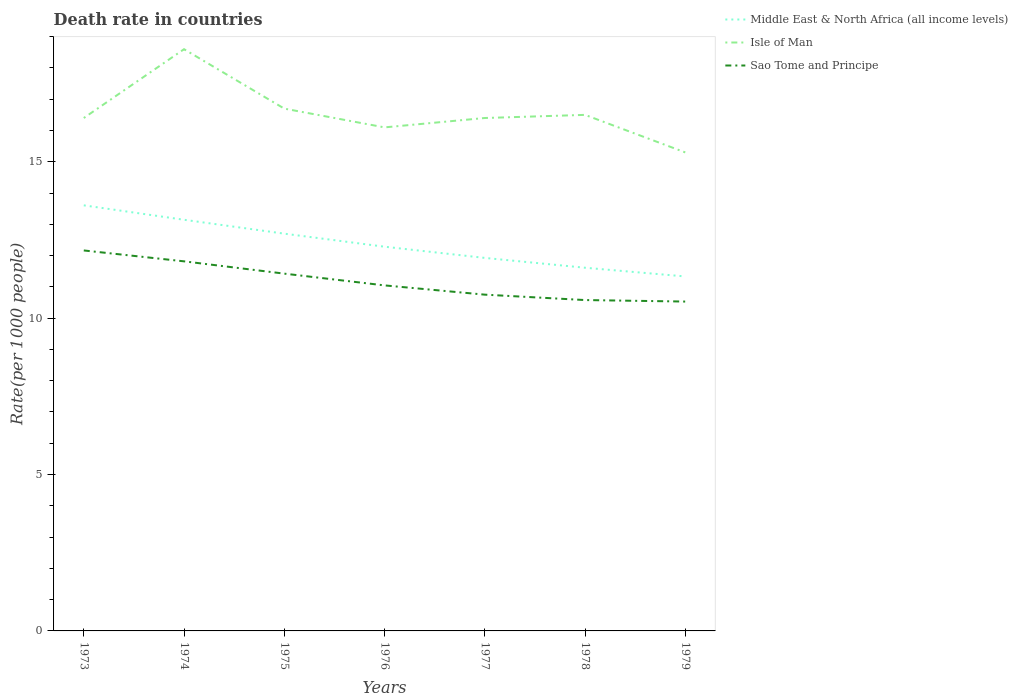Does the line corresponding to Middle East & North Africa (all income levels) intersect with the line corresponding to Isle of Man?
Give a very brief answer. No. Across all years, what is the maximum death rate in Middle East & North Africa (all income levels)?
Provide a succinct answer. 11.33. In which year was the death rate in Middle East & North Africa (all income levels) maximum?
Your answer should be very brief. 1979. What is the total death rate in Sao Tome and Principe in the graph?
Provide a succinct answer. 0.35. What is the difference between the highest and the second highest death rate in Sao Tome and Principe?
Provide a short and direct response. 1.63. What is the difference between the highest and the lowest death rate in Middle East & North Africa (all income levels)?
Provide a succinct answer. 3. Is the death rate in Isle of Man strictly greater than the death rate in Sao Tome and Principe over the years?
Your response must be concise. No. Does the graph contain any zero values?
Your response must be concise. No. Does the graph contain grids?
Your response must be concise. No. Where does the legend appear in the graph?
Ensure brevity in your answer.  Top right. What is the title of the graph?
Offer a very short reply. Death rate in countries. What is the label or title of the X-axis?
Keep it short and to the point. Years. What is the label or title of the Y-axis?
Make the answer very short. Rate(per 1000 people). What is the Rate(per 1000 people) in Middle East & North Africa (all income levels) in 1973?
Offer a terse response. 13.61. What is the Rate(per 1000 people) of Sao Tome and Principe in 1973?
Provide a short and direct response. 12.16. What is the Rate(per 1000 people) of Middle East & North Africa (all income levels) in 1974?
Keep it short and to the point. 13.15. What is the Rate(per 1000 people) of Isle of Man in 1974?
Your answer should be compact. 18.6. What is the Rate(per 1000 people) in Sao Tome and Principe in 1974?
Give a very brief answer. 11.82. What is the Rate(per 1000 people) in Middle East & North Africa (all income levels) in 1975?
Provide a succinct answer. 12.7. What is the Rate(per 1000 people) of Isle of Man in 1975?
Your answer should be very brief. 16.7. What is the Rate(per 1000 people) in Sao Tome and Principe in 1975?
Provide a short and direct response. 11.42. What is the Rate(per 1000 people) of Middle East & North Africa (all income levels) in 1976?
Offer a terse response. 12.29. What is the Rate(per 1000 people) of Sao Tome and Principe in 1976?
Your answer should be very brief. 11.05. What is the Rate(per 1000 people) in Middle East & North Africa (all income levels) in 1977?
Your answer should be very brief. 11.93. What is the Rate(per 1000 people) of Sao Tome and Principe in 1977?
Provide a short and direct response. 10.75. What is the Rate(per 1000 people) of Middle East & North Africa (all income levels) in 1978?
Give a very brief answer. 11.61. What is the Rate(per 1000 people) of Sao Tome and Principe in 1978?
Provide a short and direct response. 10.58. What is the Rate(per 1000 people) in Middle East & North Africa (all income levels) in 1979?
Make the answer very short. 11.33. What is the Rate(per 1000 people) in Sao Tome and Principe in 1979?
Make the answer very short. 10.53. Across all years, what is the maximum Rate(per 1000 people) of Middle East & North Africa (all income levels)?
Your response must be concise. 13.61. Across all years, what is the maximum Rate(per 1000 people) of Isle of Man?
Offer a very short reply. 18.6. Across all years, what is the maximum Rate(per 1000 people) of Sao Tome and Principe?
Keep it short and to the point. 12.16. Across all years, what is the minimum Rate(per 1000 people) in Middle East & North Africa (all income levels)?
Provide a succinct answer. 11.33. Across all years, what is the minimum Rate(per 1000 people) of Sao Tome and Principe?
Make the answer very short. 10.53. What is the total Rate(per 1000 people) of Middle East & North Africa (all income levels) in the graph?
Offer a terse response. 86.61. What is the total Rate(per 1000 people) of Isle of Man in the graph?
Your answer should be very brief. 116. What is the total Rate(per 1000 people) in Sao Tome and Principe in the graph?
Give a very brief answer. 78.32. What is the difference between the Rate(per 1000 people) in Middle East & North Africa (all income levels) in 1973 and that in 1974?
Your answer should be very brief. 0.46. What is the difference between the Rate(per 1000 people) in Sao Tome and Principe in 1973 and that in 1974?
Give a very brief answer. 0.35. What is the difference between the Rate(per 1000 people) of Middle East & North Africa (all income levels) in 1973 and that in 1975?
Provide a short and direct response. 0.91. What is the difference between the Rate(per 1000 people) in Sao Tome and Principe in 1973 and that in 1975?
Offer a terse response. 0.74. What is the difference between the Rate(per 1000 people) of Middle East & North Africa (all income levels) in 1973 and that in 1976?
Keep it short and to the point. 1.32. What is the difference between the Rate(per 1000 people) in Sao Tome and Principe in 1973 and that in 1976?
Offer a very short reply. 1.12. What is the difference between the Rate(per 1000 people) of Middle East & North Africa (all income levels) in 1973 and that in 1977?
Make the answer very short. 1.68. What is the difference between the Rate(per 1000 people) of Isle of Man in 1973 and that in 1977?
Provide a short and direct response. 0. What is the difference between the Rate(per 1000 people) of Sao Tome and Principe in 1973 and that in 1977?
Provide a succinct answer. 1.41. What is the difference between the Rate(per 1000 people) of Middle East & North Africa (all income levels) in 1973 and that in 1978?
Your answer should be very brief. 2. What is the difference between the Rate(per 1000 people) of Isle of Man in 1973 and that in 1978?
Your response must be concise. -0.1. What is the difference between the Rate(per 1000 people) of Sao Tome and Principe in 1973 and that in 1978?
Your response must be concise. 1.59. What is the difference between the Rate(per 1000 people) in Middle East & North Africa (all income levels) in 1973 and that in 1979?
Your answer should be very brief. 2.27. What is the difference between the Rate(per 1000 people) of Isle of Man in 1973 and that in 1979?
Give a very brief answer. 1.1. What is the difference between the Rate(per 1000 people) of Sao Tome and Principe in 1973 and that in 1979?
Your response must be concise. 1.63. What is the difference between the Rate(per 1000 people) of Middle East & North Africa (all income levels) in 1974 and that in 1975?
Your response must be concise. 0.44. What is the difference between the Rate(per 1000 people) of Isle of Man in 1974 and that in 1975?
Provide a succinct answer. 1.9. What is the difference between the Rate(per 1000 people) of Sao Tome and Principe in 1974 and that in 1975?
Your answer should be compact. 0.39. What is the difference between the Rate(per 1000 people) in Middle East & North Africa (all income levels) in 1974 and that in 1976?
Provide a short and direct response. 0.86. What is the difference between the Rate(per 1000 people) in Sao Tome and Principe in 1974 and that in 1976?
Offer a terse response. 0.77. What is the difference between the Rate(per 1000 people) in Middle East & North Africa (all income levels) in 1974 and that in 1977?
Your answer should be compact. 1.22. What is the difference between the Rate(per 1000 people) of Isle of Man in 1974 and that in 1977?
Offer a very short reply. 2.2. What is the difference between the Rate(per 1000 people) in Sao Tome and Principe in 1974 and that in 1977?
Ensure brevity in your answer.  1.06. What is the difference between the Rate(per 1000 people) of Middle East & North Africa (all income levels) in 1974 and that in 1978?
Keep it short and to the point. 1.53. What is the difference between the Rate(per 1000 people) of Isle of Man in 1974 and that in 1978?
Offer a very short reply. 2.1. What is the difference between the Rate(per 1000 people) of Sao Tome and Principe in 1974 and that in 1978?
Your answer should be compact. 1.24. What is the difference between the Rate(per 1000 people) of Middle East & North Africa (all income levels) in 1974 and that in 1979?
Give a very brief answer. 1.81. What is the difference between the Rate(per 1000 people) of Isle of Man in 1974 and that in 1979?
Make the answer very short. 3.3. What is the difference between the Rate(per 1000 people) in Sao Tome and Principe in 1974 and that in 1979?
Your answer should be very brief. 1.29. What is the difference between the Rate(per 1000 people) in Middle East & North Africa (all income levels) in 1975 and that in 1976?
Provide a succinct answer. 0.42. What is the difference between the Rate(per 1000 people) in Sao Tome and Principe in 1975 and that in 1976?
Keep it short and to the point. 0.38. What is the difference between the Rate(per 1000 people) in Middle East & North Africa (all income levels) in 1975 and that in 1977?
Offer a terse response. 0.78. What is the difference between the Rate(per 1000 people) in Sao Tome and Principe in 1975 and that in 1977?
Your answer should be very brief. 0.67. What is the difference between the Rate(per 1000 people) in Middle East & North Africa (all income levels) in 1975 and that in 1978?
Your answer should be compact. 1.09. What is the difference between the Rate(per 1000 people) in Sao Tome and Principe in 1975 and that in 1978?
Offer a terse response. 0.84. What is the difference between the Rate(per 1000 people) in Middle East & North Africa (all income levels) in 1975 and that in 1979?
Your answer should be very brief. 1.37. What is the difference between the Rate(per 1000 people) in Sao Tome and Principe in 1975 and that in 1979?
Your response must be concise. 0.89. What is the difference between the Rate(per 1000 people) in Middle East & North Africa (all income levels) in 1976 and that in 1977?
Provide a succinct answer. 0.36. What is the difference between the Rate(per 1000 people) in Sao Tome and Principe in 1976 and that in 1977?
Your answer should be compact. 0.3. What is the difference between the Rate(per 1000 people) of Middle East & North Africa (all income levels) in 1976 and that in 1978?
Provide a succinct answer. 0.67. What is the difference between the Rate(per 1000 people) in Sao Tome and Principe in 1976 and that in 1978?
Give a very brief answer. 0.47. What is the difference between the Rate(per 1000 people) of Middle East & North Africa (all income levels) in 1976 and that in 1979?
Your answer should be compact. 0.95. What is the difference between the Rate(per 1000 people) of Isle of Man in 1976 and that in 1979?
Ensure brevity in your answer.  0.8. What is the difference between the Rate(per 1000 people) of Sao Tome and Principe in 1976 and that in 1979?
Ensure brevity in your answer.  0.52. What is the difference between the Rate(per 1000 people) in Middle East & North Africa (all income levels) in 1977 and that in 1978?
Provide a succinct answer. 0.31. What is the difference between the Rate(per 1000 people) in Sao Tome and Principe in 1977 and that in 1978?
Keep it short and to the point. 0.17. What is the difference between the Rate(per 1000 people) of Middle East & North Africa (all income levels) in 1977 and that in 1979?
Your response must be concise. 0.59. What is the difference between the Rate(per 1000 people) in Isle of Man in 1977 and that in 1979?
Your answer should be very brief. 1.1. What is the difference between the Rate(per 1000 people) of Sao Tome and Principe in 1977 and that in 1979?
Give a very brief answer. 0.22. What is the difference between the Rate(per 1000 people) of Middle East & North Africa (all income levels) in 1978 and that in 1979?
Make the answer very short. 0.28. What is the difference between the Rate(per 1000 people) of Sao Tome and Principe in 1978 and that in 1979?
Your answer should be very brief. 0.05. What is the difference between the Rate(per 1000 people) in Middle East & North Africa (all income levels) in 1973 and the Rate(per 1000 people) in Isle of Man in 1974?
Ensure brevity in your answer.  -4.99. What is the difference between the Rate(per 1000 people) of Middle East & North Africa (all income levels) in 1973 and the Rate(per 1000 people) of Sao Tome and Principe in 1974?
Your response must be concise. 1.79. What is the difference between the Rate(per 1000 people) in Isle of Man in 1973 and the Rate(per 1000 people) in Sao Tome and Principe in 1974?
Provide a short and direct response. 4.58. What is the difference between the Rate(per 1000 people) of Middle East & North Africa (all income levels) in 1973 and the Rate(per 1000 people) of Isle of Man in 1975?
Ensure brevity in your answer.  -3.09. What is the difference between the Rate(per 1000 people) of Middle East & North Africa (all income levels) in 1973 and the Rate(per 1000 people) of Sao Tome and Principe in 1975?
Provide a succinct answer. 2.18. What is the difference between the Rate(per 1000 people) in Isle of Man in 1973 and the Rate(per 1000 people) in Sao Tome and Principe in 1975?
Make the answer very short. 4.98. What is the difference between the Rate(per 1000 people) of Middle East & North Africa (all income levels) in 1973 and the Rate(per 1000 people) of Isle of Man in 1976?
Ensure brevity in your answer.  -2.49. What is the difference between the Rate(per 1000 people) in Middle East & North Africa (all income levels) in 1973 and the Rate(per 1000 people) in Sao Tome and Principe in 1976?
Your answer should be very brief. 2.56. What is the difference between the Rate(per 1000 people) in Isle of Man in 1973 and the Rate(per 1000 people) in Sao Tome and Principe in 1976?
Your response must be concise. 5.35. What is the difference between the Rate(per 1000 people) of Middle East & North Africa (all income levels) in 1973 and the Rate(per 1000 people) of Isle of Man in 1977?
Keep it short and to the point. -2.79. What is the difference between the Rate(per 1000 people) of Middle East & North Africa (all income levels) in 1973 and the Rate(per 1000 people) of Sao Tome and Principe in 1977?
Offer a very short reply. 2.86. What is the difference between the Rate(per 1000 people) of Isle of Man in 1973 and the Rate(per 1000 people) of Sao Tome and Principe in 1977?
Your answer should be very brief. 5.65. What is the difference between the Rate(per 1000 people) of Middle East & North Africa (all income levels) in 1973 and the Rate(per 1000 people) of Isle of Man in 1978?
Your response must be concise. -2.89. What is the difference between the Rate(per 1000 people) in Middle East & North Africa (all income levels) in 1973 and the Rate(per 1000 people) in Sao Tome and Principe in 1978?
Your answer should be compact. 3.03. What is the difference between the Rate(per 1000 people) of Isle of Man in 1973 and the Rate(per 1000 people) of Sao Tome and Principe in 1978?
Your answer should be compact. 5.82. What is the difference between the Rate(per 1000 people) in Middle East & North Africa (all income levels) in 1973 and the Rate(per 1000 people) in Isle of Man in 1979?
Provide a short and direct response. -1.69. What is the difference between the Rate(per 1000 people) in Middle East & North Africa (all income levels) in 1973 and the Rate(per 1000 people) in Sao Tome and Principe in 1979?
Provide a succinct answer. 3.08. What is the difference between the Rate(per 1000 people) of Isle of Man in 1973 and the Rate(per 1000 people) of Sao Tome and Principe in 1979?
Offer a terse response. 5.87. What is the difference between the Rate(per 1000 people) of Middle East & North Africa (all income levels) in 1974 and the Rate(per 1000 people) of Isle of Man in 1975?
Give a very brief answer. -3.55. What is the difference between the Rate(per 1000 people) in Middle East & North Africa (all income levels) in 1974 and the Rate(per 1000 people) in Sao Tome and Principe in 1975?
Offer a very short reply. 1.72. What is the difference between the Rate(per 1000 people) of Isle of Man in 1974 and the Rate(per 1000 people) of Sao Tome and Principe in 1975?
Give a very brief answer. 7.18. What is the difference between the Rate(per 1000 people) of Middle East & North Africa (all income levels) in 1974 and the Rate(per 1000 people) of Isle of Man in 1976?
Make the answer very short. -2.95. What is the difference between the Rate(per 1000 people) in Middle East & North Africa (all income levels) in 1974 and the Rate(per 1000 people) in Sao Tome and Principe in 1976?
Your answer should be compact. 2.1. What is the difference between the Rate(per 1000 people) of Isle of Man in 1974 and the Rate(per 1000 people) of Sao Tome and Principe in 1976?
Give a very brief answer. 7.55. What is the difference between the Rate(per 1000 people) of Middle East & North Africa (all income levels) in 1974 and the Rate(per 1000 people) of Isle of Man in 1977?
Give a very brief answer. -3.25. What is the difference between the Rate(per 1000 people) of Middle East & North Africa (all income levels) in 1974 and the Rate(per 1000 people) of Sao Tome and Principe in 1977?
Give a very brief answer. 2.39. What is the difference between the Rate(per 1000 people) of Isle of Man in 1974 and the Rate(per 1000 people) of Sao Tome and Principe in 1977?
Make the answer very short. 7.85. What is the difference between the Rate(per 1000 people) in Middle East & North Africa (all income levels) in 1974 and the Rate(per 1000 people) in Isle of Man in 1978?
Your answer should be compact. -3.35. What is the difference between the Rate(per 1000 people) in Middle East & North Africa (all income levels) in 1974 and the Rate(per 1000 people) in Sao Tome and Principe in 1978?
Offer a very short reply. 2.57. What is the difference between the Rate(per 1000 people) of Isle of Man in 1974 and the Rate(per 1000 people) of Sao Tome and Principe in 1978?
Provide a short and direct response. 8.02. What is the difference between the Rate(per 1000 people) in Middle East & North Africa (all income levels) in 1974 and the Rate(per 1000 people) in Isle of Man in 1979?
Provide a succinct answer. -2.15. What is the difference between the Rate(per 1000 people) in Middle East & North Africa (all income levels) in 1974 and the Rate(per 1000 people) in Sao Tome and Principe in 1979?
Your answer should be compact. 2.62. What is the difference between the Rate(per 1000 people) in Isle of Man in 1974 and the Rate(per 1000 people) in Sao Tome and Principe in 1979?
Provide a short and direct response. 8.07. What is the difference between the Rate(per 1000 people) in Middle East & North Africa (all income levels) in 1975 and the Rate(per 1000 people) in Isle of Man in 1976?
Your answer should be very brief. -3.4. What is the difference between the Rate(per 1000 people) of Middle East & North Africa (all income levels) in 1975 and the Rate(per 1000 people) of Sao Tome and Principe in 1976?
Make the answer very short. 1.65. What is the difference between the Rate(per 1000 people) of Isle of Man in 1975 and the Rate(per 1000 people) of Sao Tome and Principe in 1976?
Ensure brevity in your answer.  5.65. What is the difference between the Rate(per 1000 people) in Middle East & North Africa (all income levels) in 1975 and the Rate(per 1000 people) in Isle of Man in 1977?
Offer a terse response. -3.7. What is the difference between the Rate(per 1000 people) in Middle East & North Africa (all income levels) in 1975 and the Rate(per 1000 people) in Sao Tome and Principe in 1977?
Keep it short and to the point. 1.95. What is the difference between the Rate(per 1000 people) in Isle of Man in 1975 and the Rate(per 1000 people) in Sao Tome and Principe in 1977?
Provide a succinct answer. 5.95. What is the difference between the Rate(per 1000 people) of Middle East & North Africa (all income levels) in 1975 and the Rate(per 1000 people) of Isle of Man in 1978?
Give a very brief answer. -3.8. What is the difference between the Rate(per 1000 people) of Middle East & North Africa (all income levels) in 1975 and the Rate(per 1000 people) of Sao Tome and Principe in 1978?
Offer a very short reply. 2.12. What is the difference between the Rate(per 1000 people) of Isle of Man in 1975 and the Rate(per 1000 people) of Sao Tome and Principe in 1978?
Your answer should be compact. 6.12. What is the difference between the Rate(per 1000 people) in Middle East & North Africa (all income levels) in 1975 and the Rate(per 1000 people) in Isle of Man in 1979?
Ensure brevity in your answer.  -2.6. What is the difference between the Rate(per 1000 people) in Middle East & North Africa (all income levels) in 1975 and the Rate(per 1000 people) in Sao Tome and Principe in 1979?
Make the answer very short. 2.17. What is the difference between the Rate(per 1000 people) of Isle of Man in 1975 and the Rate(per 1000 people) of Sao Tome and Principe in 1979?
Offer a very short reply. 6.17. What is the difference between the Rate(per 1000 people) in Middle East & North Africa (all income levels) in 1976 and the Rate(per 1000 people) in Isle of Man in 1977?
Provide a short and direct response. -4.12. What is the difference between the Rate(per 1000 people) of Middle East & North Africa (all income levels) in 1976 and the Rate(per 1000 people) of Sao Tome and Principe in 1977?
Your answer should be very brief. 1.53. What is the difference between the Rate(per 1000 people) in Isle of Man in 1976 and the Rate(per 1000 people) in Sao Tome and Principe in 1977?
Offer a terse response. 5.35. What is the difference between the Rate(per 1000 people) in Middle East & North Africa (all income levels) in 1976 and the Rate(per 1000 people) in Isle of Man in 1978?
Provide a short and direct response. -4.21. What is the difference between the Rate(per 1000 people) in Middle East & North Africa (all income levels) in 1976 and the Rate(per 1000 people) in Sao Tome and Principe in 1978?
Your answer should be compact. 1.71. What is the difference between the Rate(per 1000 people) in Isle of Man in 1976 and the Rate(per 1000 people) in Sao Tome and Principe in 1978?
Provide a succinct answer. 5.52. What is the difference between the Rate(per 1000 people) of Middle East & North Africa (all income levels) in 1976 and the Rate(per 1000 people) of Isle of Man in 1979?
Ensure brevity in your answer.  -3.02. What is the difference between the Rate(per 1000 people) of Middle East & North Africa (all income levels) in 1976 and the Rate(per 1000 people) of Sao Tome and Principe in 1979?
Make the answer very short. 1.75. What is the difference between the Rate(per 1000 people) in Isle of Man in 1976 and the Rate(per 1000 people) in Sao Tome and Principe in 1979?
Offer a very short reply. 5.57. What is the difference between the Rate(per 1000 people) in Middle East & North Africa (all income levels) in 1977 and the Rate(per 1000 people) in Isle of Man in 1978?
Provide a short and direct response. -4.57. What is the difference between the Rate(per 1000 people) in Middle East & North Africa (all income levels) in 1977 and the Rate(per 1000 people) in Sao Tome and Principe in 1978?
Keep it short and to the point. 1.35. What is the difference between the Rate(per 1000 people) in Isle of Man in 1977 and the Rate(per 1000 people) in Sao Tome and Principe in 1978?
Offer a terse response. 5.82. What is the difference between the Rate(per 1000 people) in Middle East & North Africa (all income levels) in 1977 and the Rate(per 1000 people) in Isle of Man in 1979?
Keep it short and to the point. -3.37. What is the difference between the Rate(per 1000 people) of Middle East & North Africa (all income levels) in 1977 and the Rate(per 1000 people) of Sao Tome and Principe in 1979?
Offer a terse response. 1.4. What is the difference between the Rate(per 1000 people) in Isle of Man in 1977 and the Rate(per 1000 people) in Sao Tome and Principe in 1979?
Offer a very short reply. 5.87. What is the difference between the Rate(per 1000 people) of Middle East & North Africa (all income levels) in 1978 and the Rate(per 1000 people) of Isle of Man in 1979?
Provide a succinct answer. -3.69. What is the difference between the Rate(per 1000 people) of Middle East & North Africa (all income levels) in 1978 and the Rate(per 1000 people) of Sao Tome and Principe in 1979?
Give a very brief answer. 1.08. What is the difference between the Rate(per 1000 people) in Isle of Man in 1978 and the Rate(per 1000 people) in Sao Tome and Principe in 1979?
Keep it short and to the point. 5.97. What is the average Rate(per 1000 people) in Middle East & North Africa (all income levels) per year?
Make the answer very short. 12.37. What is the average Rate(per 1000 people) of Isle of Man per year?
Make the answer very short. 16.57. What is the average Rate(per 1000 people) of Sao Tome and Principe per year?
Your response must be concise. 11.19. In the year 1973, what is the difference between the Rate(per 1000 people) in Middle East & North Africa (all income levels) and Rate(per 1000 people) in Isle of Man?
Offer a very short reply. -2.79. In the year 1973, what is the difference between the Rate(per 1000 people) of Middle East & North Africa (all income levels) and Rate(per 1000 people) of Sao Tome and Principe?
Offer a very short reply. 1.44. In the year 1973, what is the difference between the Rate(per 1000 people) of Isle of Man and Rate(per 1000 people) of Sao Tome and Principe?
Make the answer very short. 4.24. In the year 1974, what is the difference between the Rate(per 1000 people) of Middle East & North Africa (all income levels) and Rate(per 1000 people) of Isle of Man?
Offer a very short reply. -5.45. In the year 1974, what is the difference between the Rate(per 1000 people) in Middle East & North Africa (all income levels) and Rate(per 1000 people) in Sao Tome and Principe?
Your answer should be compact. 1.33. In the year 1974, what is the difference between the Rate(per 1000 people) in Isle of Man and Rate(per 1000 people) in Sao Tome and Principe?
Offer a terse response. 6.78. In the year 1975, what is the difference between the Rate(per 1000 people) of Middle East & North Africa (all income levels) and Rate(per 1000 people) of Isle of Man?
Offer a terse response. -4. In the year 1975, what is the difference between the Rate(per 1000 people) in Middle East & North Africa (all income levels) and Rate(per 1000 people) in Sao Tome and Principe?
Provide a short and direct response. 1.28. In the year 1975, what is the difference between the Rate(per 1000 people) of Isle of Man and Rate(per 1000 people) of Sao Tome and Principe?
Your response must be concise. 5.28. In the year 1976, what is the difference between the Rate(per 1000 people) in Middle East & North Africa (all income levels) and Rate(per 1000 people) in Isle of Man?
Ensure brevity in your answer.  -3.81. In the year 1976, what is the difference between the Rate(per 1000 people) in Middle East & North Africa (all income levels) and Rate(per 1000 people) in Sao Tome and Principe?
Keep it short and to the point. 1.24. In the year 1976, what is the difference between the Rate(per 1000 people) in Isle of Man and Rate(per 1000 people) in Sao Tome and Principe?
Make the answer very short. 5.05. In the year 1977, what is the difference between the Rate(per 1000 people) in Middle East & North Africa (all income levels) and Rate(per 1000 people) in Isle of Man?
Your answer should be very brief. -4.47. In the year 1977, what is the difference between the Rate(per 1000 people) in Middle East & North Africa (all income levels) and Rate(per 1000 people) in Sao Tome and Principe?
Offer a terse response. 1.17. In the year 1977, what is the difference between the Rate(per 1000 people) of Isle of Man and Rate(per 1000 people) of Sao Tome and Principe?
Your response must be concise. 5.65. In the year 1978, what is the difference between the Rate(per 1000 people) in Middle East & North Africa (all income levels) and Rate(per 1000 people) in Isle of Man?
Provide a succinct answer. -4.89. In the year 1978, what is the difference between the Rate(per 1000 people) of Middle East & North Africa (all income levels) and Rate(per 1000 people) of Sao Tome and Principe?
Your answer should be compact. 1.03. In the year 1978, what is the difference between the Rate(per 1000 people) of Isle of Man and Rate(per 1000 people) of Sao Tome and Principe?
Ensure brevity in your answer.  5.92. In the year 1979, what is the difference between the Rate(per 1000 people) in Middle East & North Africa (all income levels) and Rate(per 1000 people) in Isle of Man?
Provide a succinct answer. -3.97. In the year 1979, what is the difference between the Rate(per 1000 people) of Middle East & North Africa (all income levels) and Rate(per 1000 people) of Sao Tome and Principe?
Ensure brevity in your answer.  0.8. In the year 1979, what is the difference between the Rate(per 1000 people) of Isle of Man and Rate(per 1000 people) of Sao Tome and Principe?
Provide a succinct answer. 4.77. What is the ratio of the Rate(per 1000 people) of Middle East & North Africa (all income levels) in 1973 to that in 1974?
Offer a terse response. 1.04. What is the ratio of the Rate(per 1000 people) in Isle of Man in 1973 to that in 1974?
Your answer should be compact. 0.88. What is the ratio of the Rate(per 1000 people) of Sao Tome and Principe in 1973 to that in 1974?
Your answer should be compact. 1.03. What is the ratio of the Rate(per 1000 people) in Middle East & North Africa (all income levels) in 1973 to that in 1975?
Ensure brevity in your answer.  1.07. What is the ratio of the Rate(per 1000 people) of Sao Tome and Principe in 1973 to that in 1975?
Make the answer very short. 1.06. What is the ratio of the Rate(per 1000 people) in Middle East & North Africa (all income levels) in 1973 to that in 1976?
Your response must be concise. 1.11. What is the ratio of the Rate(per 1000 people) of Isle of Man in 1973 to that in 1976?
Make the answer very short. 1.02. What is the ratio of the Rate(per 1000 people) in Sao Tome and Principe in 1973 to that in 1976?
Your response must be concise. 1.1. What is the ratio of the Rate(per 1000 people) in Middle East & North Africa (all income levels) in 1973 to that in 1977?
Your answer should be very brief. 1.14. What is the ratio of the Rate(per 1000 people) of Sao Tome and Principe in 1973 to that in 1977?
Keep it short and to the point. 1.13. What is the ratio of the Rate(per 1000 people) of Middle East & North Africa (all income levels) in 1973 to that in 1978?
Your answer should be compact. 1.17. What is the ratio of the Rate(per 1000 people) in Isle of Man in 1973 to that in 1978?
Keep it short and to the point. 0.99. What is the ratio of the Rate(per 1000 people) of Sao Tome and Principe in 1973 to that in 1978?
Provide a succinct answer. 1.15. What is the ratio of the Rate(per 1000 people) in Middle East & North Africa (all income levels) in 1973 to that in 1979?
Offer a very short reply. 1.2. What is the ratio of the Rate(per 1000 people) in Isle of Man in 1973 to that in 1979?
Your answer should be compact. 1.07. What is the ratio of the Rate(per 1000 people) in Sao Tome and Principe in 1973 to that in 1979?
Keep it short and to the point. 1.16. What is the ratio of the Rate(per 1000 people) in Middle East & North Africa (all income levels) in 1974 to that in 1975?
Offer a terse response. 1.03. What is the ratio of the Rate(per 1000 people) of Isle of Man in 1974 to that in 1975?
Provide a short and direct response. 1.11. What is the ratio of the Rate(per 1000 people) in Sao Tome and Principe in 1974 to that in 1975?
Keep it short and to the point. 1.03. What is the ratio of the Rate(per 1000 people) in Middle East & North Africa (all income levels) in 1974 to that in 1976?
Keep it short and to the point. 1.07. What is the ratio of the Rate(per 1000 people) of Isle of Man in 1974 to that in 1976?
Offer a very short reply. 1.16. What is the ratio of the Rate(per 1000 people) of Sao Tome and Principe in 1974 to that in 1976?
Give a very brief answer. 1.07. What is the ratio of the Rate(per 1000 people) of Middle East & North Africa (all income levels) in 1974 to that in 1977?
Keep it short and to the point. 1.1. What is the ratio of the Rate(per 1000 people) of Isle of Man in 1974 to that in 1977?
Keep it short and to the point. 1.13. What is the ratio of the Rate(per 1000 people) of Sao Tome and Principe in 1974 to that in 1977?
Keep it short and to the point. 1.1. What is the ratio of the Rate(per 1000 people) in Middle East & North Africa (all income levels) in 1974 to that in 1978?
Your answer should be very brief. 1.13. What is the ratio of the Rate(per 1000 people) in Isle of Man in 1974 to that in 1978?
Keep it short and to the point. 1.13. What is the ratio of the Rate(per 1000 people) of Sao Tome and Principe in 1974 to that in 1978?
Give a very brief answer. 1.12. What is the ratio of the Rate(per 1000 people) in Middle East & North Africa (all income levels) in 1974 to that in 1979?
Provide a short and direct response. 1.16. What is the ratio of the Rate(per 1000 people) of Isle of Man in 1974 to that in 1979?
Your answer should be very brief. 1.22. What is the ratio of the Rate(per 1000 people) in Sao Tome and Principe in 1974 to that in 1979?
Your answer should be very brief. 1.12. What is the ratio of the Rate(per 1000 people) in Middle East & North Africa (all income levels) in 1975 to that in 1976?
Your response must be concise. 1.03. What is the ratio of the Rate(per 1000 people) in Isle of Man in 1975 to that in 1976?
Offer a terse response. 1.04. What is the ratio of the Rate(per 1000 people) of Sao Tome and Principe in 1975 to that in 1976?
Keep it short and to the point. 1.03. What is the ratio of the Rate(per 1000 people) of Middle East & North Africa (all income levels) in 1975 to that in 1977?
Your answer should be compact. 1.06. What is the ratio of the Rate(per 1000 people) in Isle of Man in 1975 to that in 1977?
Give a very brief answer. 1.02. What is the ratio of the Rate(per 1000 people) of Middle East & North Africa (all income levels) in 1975 to that in 1978?
Your answer should be very brief. 1.09. What is the ratio of the Rate(per 1000 people) in Isle of Man in 1975 to that in 1978?
Keep it short and to the point. 1.01. What is the ratio of the Rate(per 1000 people) in Sao Tome and Principe in 1975 to that in 1978?
Your response must be concise. 1.08. What is the ratio of the Rate(per 1000 people) of Middle East & North Africa (all income levels) in 1975 to that in 1979?
Keep it short and to the point. 1.12. What is the ratio of the Rate(per 1000 people) in Isle of Man in 1975 to that in 1979?
Offer a terse response. 1.09. What is the ratio of the Rate(per 1000 people) in Sao Tome and Principe in 1975 to that in 1979?
Offer a very short reply. 1.08. What is the ratio of the Rate(per 1000 people) of Middle East & North Africa (all income levels) in 1976 to that in 1977?
Your answer should be very brief. 1.03. What is the ratio of the Rate(per 1000 people) in Isle of Man in 1976 to that in 1977?
Provide a short and direct response. 0.98. What is the ratio of the Rate(per 1000 people) of Sao Tome and Principe in 1976 to that in 1977?
Offer a terse response. 1.03. What is the ratio of the Rate(per 1000 people) in Middle East & North Africa (all income levels) in 1976 to that in 1978?
Your answer should be very brief. 1.06. What is the ratio of the Rate(per 1000 people) in Isle of Man in 1976 to that in 1978?
Your response must be concise. 0.98. What is the ratio of the Rate(per 1000 people) in Sao Tome and Principe in 1976 to that in 1978?
Ensure brevity in your answer.  1.04. What is the ratio of the Rate(per 1000 people) in Middle East & North Africa (all income levels) in 1976 to that in 1979?
Offer a terse response. 1.08. What is the ratio of the Rate(per 1000 people) in Isle of Man in 1976 to that in 1979?
Offer a very short reply. 1.05. What is the ratio of the Rate(per 1000 people) in Sao Tome and Principe in 1976 to that in 1979?
Offer a very short reply. 1.05. What is the ratio of the Rate(per 1000 people) in Middle East & North Africa (all income levels) in 1977 to that in 1978?
Offer a terse response. 1.03. What is the ratio of the Rate(per 1000 people) of Isle of Man in 1977 to that in 1978?
Offer a very short reply. 0.99. What is the ratio of the Rate(per 1000 people) of Sao Tome and Principe in 1977 to that in 1978?
Your response must be concise. 1.02. What is the ratio of the Rate(per 1000 people) of Middle East & North Africa (all income levels) in 1977 to that in 1979?
Keep it short and to the point. 1.05. What is the ratio of the Rate(per 1000 people) in Isle of Man in 1977 to that in 1979?
Offer a very short reply. 1.07. What is the ratio of the Rate(per 1000 people) of Sao Tome and Principe in 1977 to that in 1979?
Your answer should be compact. 1.02. What is the ratio of the Rate(per 1000 people) in Middle East & North Africa (all income levels) in 1978 to that in 1979?
Give a very brief answer. 1.02. What is the ratio of the Rate(per 1000 people) of Isle of Man in 1978 to that in 1979?
Provide a succinct answer. 1.08. What is the ratio of the Rate(per 1000 people) in Sao Tome and Principe in 1978 to that in 1979?
Your response must be concise. 1. What is the difference between the highest and the second highest Rate(per 1000 people) in Middle East & North Africa (all income levels)?
Provide a short and direct response. 0.46. What is the difference between the highest and the second highest Rate(per 1000 people) of Sao Tome and Principe?
Provide a succinct answer. 0.35. What is the difference between the highest and the lowest Rate(per 1000 people) in Middle East & North Africa (all income levels)?
Provide a succinct answer. 2.27. What is the difference between the highest and the lowest Rate(per 1000 people) of Isle of Man?
Make the answer very short. 3.3. What is the difference between the highest and the lowest Rate(per 1000 people) in Sao Tome and Principe?
Your answer should be compact. 1.63. 